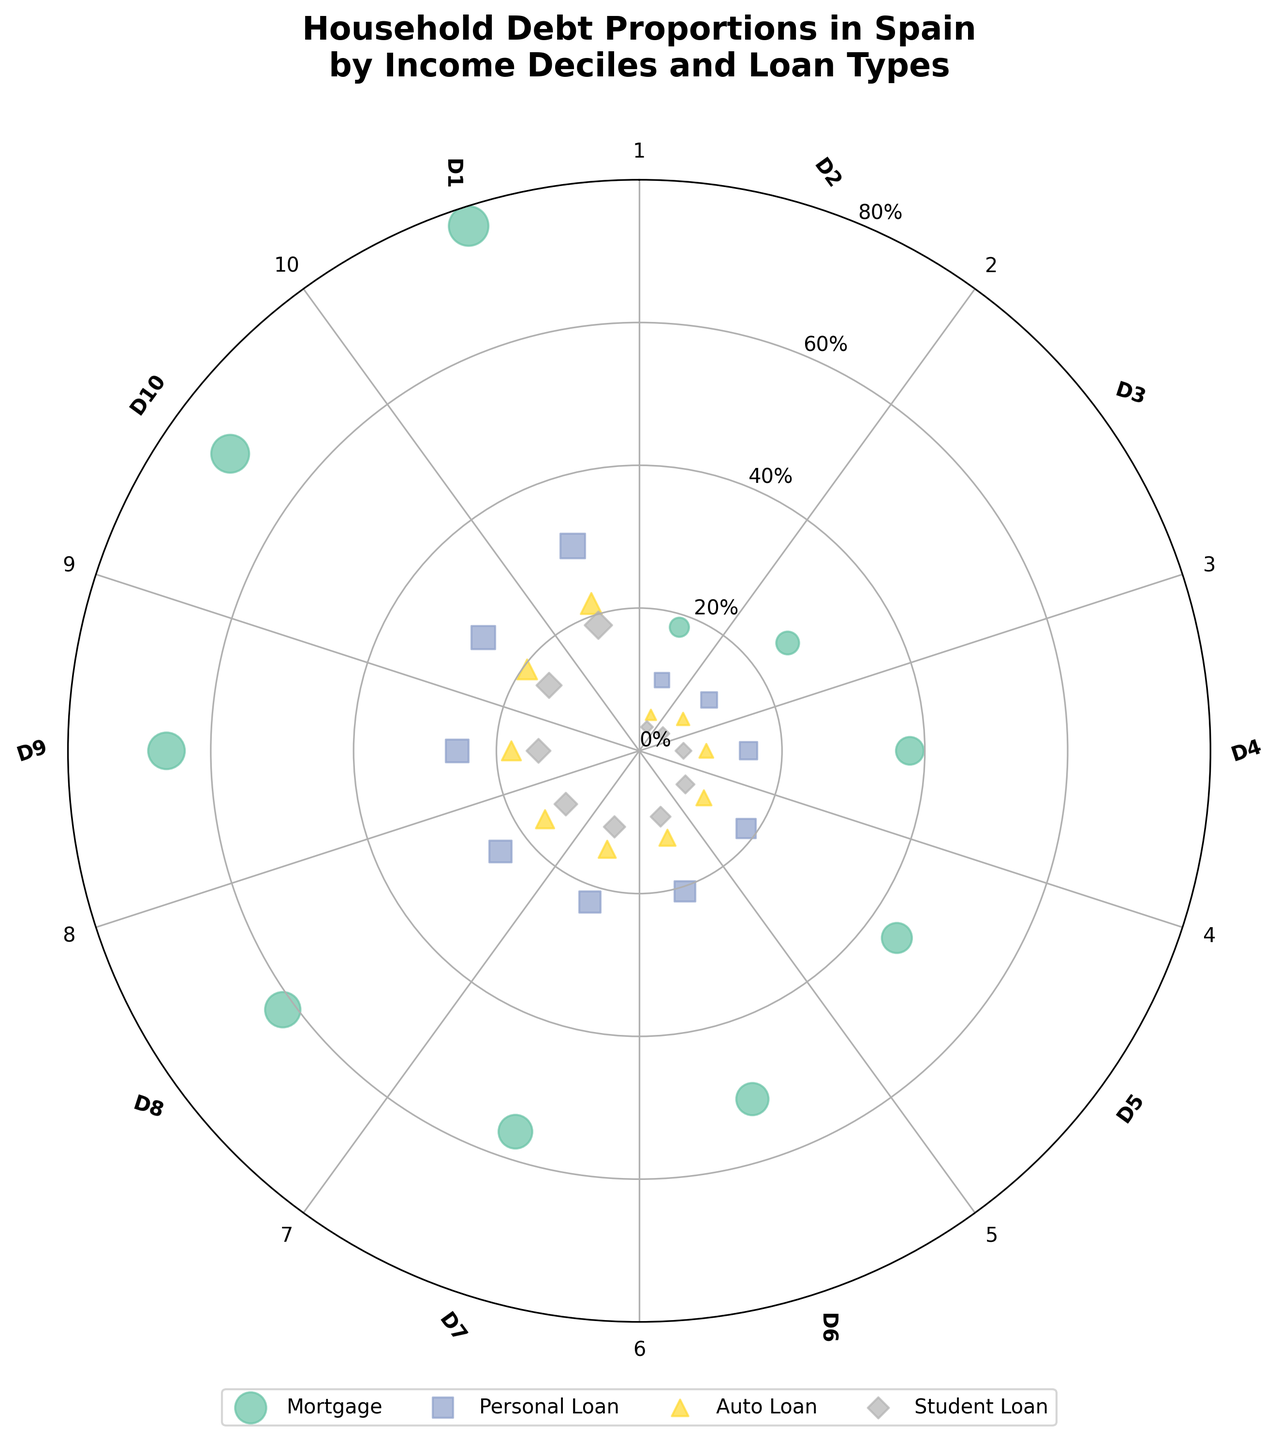What is the title of the plot? The title is usually located at the top of the plot. In this case, it's "Household Debt Proportions in Spain by Income Deciles and Loan Types".
Answer: Household Debt Proportions in Spain by Income Deciles and Loan Types How many different loan types are displayed in the figure? The plot legend shows the distinct loan types. It lists Mortgage, Personal Loan, Auto Loan, and Student Loan.
Answer: 4 Which loan type has the highest proportion for the 10th income decile? Look at the point farthest from the center for the 10th income decile. The legend and color of the markers indicate it's the Mortgage Loan.
Answer: Mortgage At which income decile does the proportion of Auto Loans cross the 15% mark? Check the plot for where the Auto Loan (indicated by a specific marker) proportion surpasses the 15% radial line. This happens at the 7th income decile.
Answer: 7th income decile Compare the proportion of Student Loans between the 1st and 10th income deciles. Which one is higher and by how much? Locate the Student Loan markers for both deciles. The 1st decile has 3.5% and the 10th has 18.5%. The difference is 18.5% - 3.5% = 15%.
Answer: 10th decile by 15% What is the approximate average proportion of Personal Loans across all income deciles? Sum the proportions of Personal Loans for all deciles (10.4 + 12.1 + 15.3 + 18.5 + 20.7 + 22.3 + 24.0 + 25.5 + 27.0 + 30.2) then divide by 10. This results in about 20.6%.
Answer: 20.6% What trend is observed in Mortgage loan proportions as income deciles increase from 1 to 10? Sequence the Mortgage proportions by income deciles and note the pattern. There's a consistent increase in proportions from 18.2% at the 1st decile to 77.3% at the 10th.
Answer: Increasing trend Which income decile has the lowest proportion of Auto Loans? Check the points closest to the center corresponding to Auto Loans. The 1st income decile has the lowest proportion at 5.3%.
Answer: 1st income decile What's the combined proportion of Personal Loans and Student Loans for the 5th income decile? Sum the proportions: Personal Loans at 20.7% and Student Loans at 9.7%. The total is 20.7% + 9.7% = 30.4%.
Answer: 30.4% For which income decile is the proportion of Student Loans approximately equal to the proportion of Auto Loans for the 2nd income decile? The 2nd income decile has an Auto Loan proportion of 7.6%. Looking at Student Loan proportions, the 4th decile is closest at 8.0%.
Answer: 4th decile 